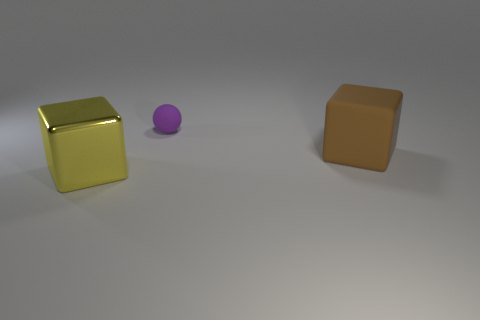Add 3 tiny brown cylinders. How many objects exist? 6 Subtract all cubes. How many objects are left? 1 Subtract all big brown matte cubes. Subtract all cubes. How many objects are left? 0 Add 2 tiny objects. How many tiny objects are left? 3 Add 2 large cyan blocks. How many large cyan blocks exist? 2 Subtract 0 green balls. How many objects are left? 3 Subtract all cyan balls. Subtract all blue cubes. How many balls are left? 1 